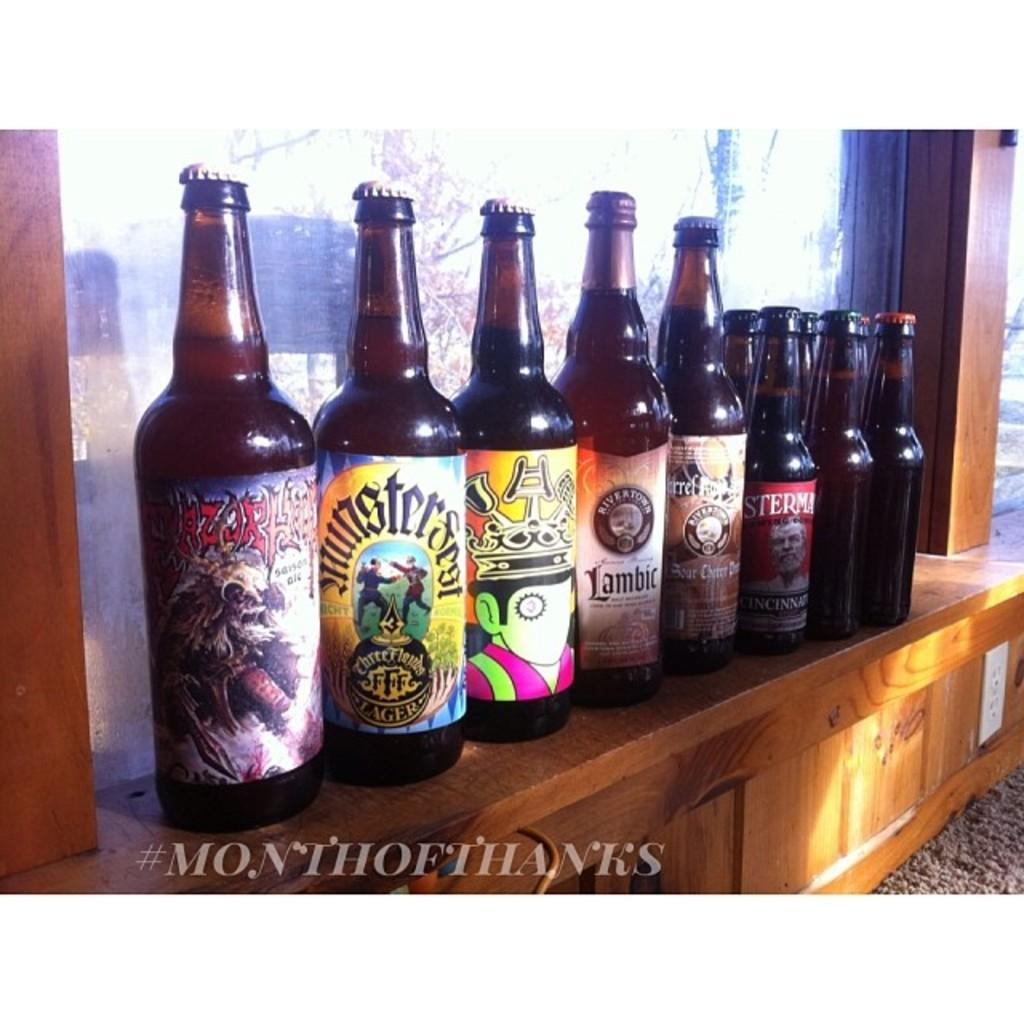<image>
Give a short and clear explanation of the subsequent image. Several bottles are lined up on a shelf including Rivertown Lambic and Munsterfest. 